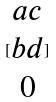Convert formula to latex. <formula><loc_0><loc_0><loc_500><loc_500>[ \begin{matrix} a c \\ b d \\ 0 \end{matrix} ]</formula> 